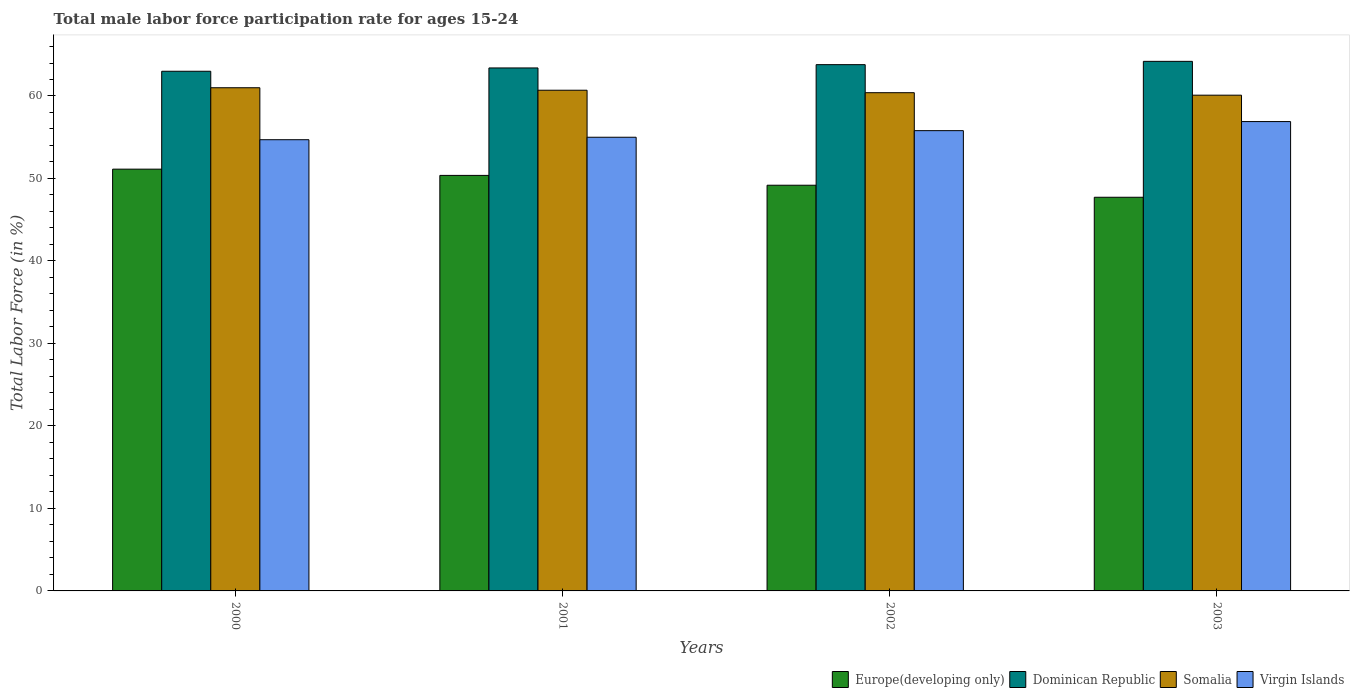How many different coloured bars are there?
Offer a very short reply. 4. Are the number of bars per tick equal to the number of legend labels?
Give a very brief answer. Yes. How many bars are there on the 3rd tick from the left?
Provide a short and direct response. 4. What is the male labor force participation rate in Virgin Islands in 2002?
Keep it short and to the point. 55.8. Across all years, what is the maximum male labor force participation rate in Virgin Islands?
Ensure brevity in your answer.  56.9. Across all years, what is the minimum male labor force participation rate in Somalia?
Ensure brevity in your answer.  60.1. In which year was the male labor force participation rate in Europe(developing only) maximum?
Keep it short and to the point. 2000. What is the total male labor force participation rate in Dominican Republic in the graph?
Your answer should be very brief. 254.4. What is the difference between the male labor force participation rate in Europe(developing only) in 2000 and that in 2002?
Your answer should be very brief. 1.95. What is the difference between the male labor force participation rate in Virgin Islands in 2003 and the male labor force participation rate in Europe(developing only) in 2001?
Make the answer very short. 6.52. What is the average male labor force participation rate in Somalia per year?
Give a very brief answer. 60.55. In the year 2003, what is the difference between the male labor force participation rate in Europe(developing only) and male labor force participation rate in Virgin Islands?
Provide a succinct answer. -9.18. In how many years, is the male labor force participation rate in Europe(developing only) greater than 62 %?
Provide a succinct answer. 0. What is the ratio of the male labor force participation rate in Virgin Islands in 2002 to that in 2003?
Provide a short and direct response. 0.98. Is the difference between the male labor force participation rate in Europe(developing only) in 2001 and 2003 greater than the difference between the male labor force participation rate in Virgin Islands in 2001 and 2003?
Provide a short and direct response. Yes. What is the difference between the highest and the second highest male labor force participation rate in Somalia?
Your response must be concise. 0.3. What is the difference between the highest and the lowest male labor force participation rate in Europe(developing only)?
Your answer should be compact. 3.41. Is the sum of the male labor force participation rate in Dominican Republic in 2001 and 2002 greater than the maximum male labor force participation rate in Somalia across all years?
Offer a terse response. Yes. Is it the case that in every year, the sum of the male labor force participation rate in Dominican Republic and male labor force participation rate in Somalia is greater than the sum of male labor force participation rate in Virgin Islands and male labor force participation rate in Europe(developing only)?
Keep it short and to the point. Yes. What does the 4th bar from the left in 2000 represents?
Provide a succinct answer. Virgin Islands. What does the 4th bar from the right in 2002 represents?
Keep it short and to the point. Europe(developing only). Is it the case that in every year, the sum of the male labor force participation rate in Dominican Republic and male labor force participation rate in Virgin Islands is greater than the male labor force participation rate in Europe(developing only)?
Ensure brevity in your answer.  Yes. Are all the bars in the graph horizontal?
Give a very brief answer. No. What is the difference between two consecutive major ticks on the Y-axis?
Provide a succinct answer. 10. Does the graph contain grids?
Ensure brevity in your answer.  No. How many legend labels are there?
Your response must be concise. 4. How are the legend labels stacked?
Offer a terse response. Horizontal. What is the title of the graph?
Your answer should be compact. Total male labor force participation rate for ages 15-24. Does "Austria" appear as one of the legend labels in the graph?
Your response must be concise. No. What is the label or title of the Y-axis?
Offer a terse response. Total Labor Force (in %). What is the Total Labor Force (in %) in Europe(developing only) in 2000?
Give a very brief answer. 51.13. What is the Total Labor Force (in %) in Dominican Republic in 2000?
Make the answer very short. 63. What is the Total Labor Force (in %) of Somalia in 2000?
Provide a succinct answer. 61. What is the Total Labor Force (in %) in Virgin Islands in 2000?
Keep it short and to the point. 54.7. What is the Total Labor Force (in %) in Europe(developing only) in 2001?
Ensure brevity in your answer.  50.38. What is the Total Labor Force (in %) in Dominican Republic in 2001?
Give a very brief answer. 63.4. What is the Total Labor Force (in %) in Somalia in 2001?
Provide a succinct answer. 60.7. What is the Total Labor Force (in %) of Europe(developing only) in 2002?
Provide a succinct answer. 49.18. What is the Total Labor Force (in %) of Dominican Republic in 2002?
Provide a succinct answer. 63.8. What is the Total Labor Force (in %) of Somalia in 2002?
Provide a succinct answer. 60.4. What is the Total Labor Force (in %) of Virgin Islands in 2002?
Offer a terse response. 55.8. What is the Total Labor Force (in %) in Europe(developing only) in 2003?
Keep it short and to the point. 47.72. What is the Total Labor Force (in %) of Dominican Republic in 2003?
Your answer should be very brief. 64.2. What is the Total Labor Force (in %) in Somalia in 2003?
Keep it short and to the point. 60.1. What is the Total Labor Force (in %) of Virgin Islands in 2003?
Your response must be concise. 56.9. Across all years, what is the maximum Total Labor Force (in %) in Europe(developing only)?
Provide a short and direct response. 51.13. Across all years, what is the maximum Total Labor Force (in %) in Dominican Republic?
Keep it short and to the point. 64.2. Across all years, what is the maximum Total Labor Force (in %) of Somalia?
Keep it short and to the point. 61. Across all years, what is the maximum Total Labor Force (in %) in Virgin Islands?
Ensure brevity in your answer.  56.9. Across all years, what is the minimum Total Labor Force (in %) of Europe(developing only)?
Give a very brief answer. 47.72. Across all years, what is the minimum Total Labor Force (in %) of Dominican Republic?
Your response must be concise. 63. Across all years, what is the minimum Total Labor Force (in %) in Somalia?
Keep it short and to the point. 60.1. Across all years, what is the minimum Total Labor Force (in %) in Virgin Islands?
Make the answer very short. 54.7. What is the total Total Labor Force (in %) in Europe(developing only) in the graph?
Ensure brevity in your answer.  198.42. What is the total Total Labor Force (in %) of Dominican Republic in the graph?
Your response must be concise. 254.4. What is the total Total Labor Force (in %) of Somalia in the graph?
Offer a very short reply. 242.2. What is the total Total Labor Force (in %) in Virgin Islands in the graph?
Your answer should be compact. 222.4. What is the difference between the Total Labor Force (in %) of Europe(developing only) in 2000 and that in 2001?
Your response must be concise. 0.76. What is the difference between the Total Labor Force (in %) of Somalia in 2000 and that in 2001?
Provide a short and direct response. 0.3. What is the difference between the Total Labor Force (in %) in Europe(developing only) in 2000 and that in 2002?
Your answer should be very brief. 1.95. What is the difference between the Total Labor Force (in %) of Dominican Republic in 2000 and that in 2002?
Offer a terse response. -0.8. What is the difference between the Total Labor Force (in %) in Europe(developing only) in 2000 and that in 2003?
Offer a very short reply. 3.41. What is the difference between the Total Labor Force (in %) of Virgin Islands in 2000 and that in 2003?
Make the answer very short. -2.2. What is the difference between the Total Labor Force (in %) of Europe(developing only) in 2001 and that in 2002?
Your response must be concise. 1.19. What is the difference between the Total Labor Force (in %) in Virgin Islands in 2001 and that in 2002?
Your answer should be very brief. -0.8. What is the difference between the Total Labor Force (in %) of Europe(developing only) in 2001 and that in 2003?
Ensure brevity in your answer.  2.65. What is the difference between the Total Labor Force (in %) of Dominican Republic in 2001 and that in 2003?
Provide a succinct answer. -0.8. What is the difference between the Total Labor Force (in %) in Somalia in 2001 and that in 2003?
Keep it short and to the point. 0.6. What is the difference between the Total Labor Force (in %) of Europe(developing only) in 2002 and that in 2003?
Give a very brief answer. 1.46. What is the difference between the Total Labor Force (in %) in Somalia in 2002 and that in 2003?
Your answer should be very brief. 0.3. What is the difference between the Total Labor Force (in %) in Europe(developing only) in 2000 and the Total Labor Force (in %) in Dominican Republic in 2001?
Keep it short and to the point. -12.27. What is the difference between the Total Labor Force (in %) in Europe(developing only) in 2000 and the Total Labor Force (in %) in Somalia in 2001?
Your response must be concise. -9.57. What is the difference between the Total Labor Force (in %) in Europe(developing only) in 2000 and the Total Labor Force (in %) in Virgin Islands in 2001?
Provide a short and direct response. -3.87. What is the difference between the Total Labor Force (in %) of Dominican Republic in 2000 and the Total Labor Force (in %) of Somalia in 2001?
Offer a very short reply. 2.3. What is the difference between the Total Labor Force (in %) in Dominican Republic in 2000 and the Total Labor Force (in %) in Virgin Islands in 2001?
Provide a succinct answer. 8. What is the difference between the Total Labor Force (in %) in Europe(developing only) in 2000 and the Total Labor Force (in %) in Dominican Republic in 2002?
Give a very brief answer. -12.67. What is the difference between the Total Labor Force (in %) in Europe(developing only) in 2000 and the Total Labor Force (in %) in Somalia in 2002?
Your response must be concise. -9.27. What is the difference between the Total Labor Force (in %) in Europe(developing only) in 2000 and the Total Labor Force (in %) in Virgin Islands in 2002?
Your response must be concise. -4.67. What is the difference between the Total Labor Force (in %) in Somalia in 2000 and the Total Labor Force (in %) in Virgin Islands in 2002?
Provide a short and direct response. 5.2. What is the difference between the Total Labor Force (in %) in Europe(developing only) in 2000 and the Total Labor Force (in %) in Dominican Republic in 2003?
Offer a terse response. -13.07. What is the difference between the Total Labor Force (in %) of Europe(developing only) in 2000 and the Total Labor Force (in %) of Somalia in 2003?
Your answer should be very brief. -8.97. What is the difference between the Total Labor Force (in %) in Europe(developing only) in 2000 and the Total Labor Force (in %) in Virgin Islands in 2003?
Your answer should be compact. -5.77. What is the difference between the Total Labor Force (in %) of Dominican Republic in 2000 and the Total Labor Force (in %) of Somalia in 2003?
Make the answer very short. 2.9. What is the difference between the Total Labor Force (in %) of Somalia in 2000 and the Total Labor Force (in %) of Virgin Islands in 2003?
Provide a short and direct response. 4.1. What is the difference between the Total Labor Force (in %) in Europe(developing only) in 2001 and the Total Labor Force (in %) in Dominican Republic in 2002?
Your answer should be compact. -13.42. What is the difference between the Total Labor Force (in %) in Europe(developing only) in 2001 and the Total Labor Force (in %) in Somalia in 2002?
Your response must be concise. -10.02. What is the difference between the Total Labor Force (in %) in Europe(developing only) in 2001 and the Total Labor Force (in %) in Virgin Islands in 2002?
Offer a terse response. -5.42. What is the difference between the Total Labor Force (in %) in Dominican Republic in 2001 and the Total Labor Force (in %) in Virgin Islands in 2002?
Provide a short and direct response. 7.6. What is the difference between the Total Labor Force (in %) of Somalia in 2001 and the Total Labor Force (in %) of Virgin Islands in 2002?
Provide a short and direct response. 4.9. What is the difference between the Total Labor Force (in %) in Europe(developing only) in 2001 and the Total Labor Force (in %) in Dominican Republic in 2003?
Your answer should be very brief. -13.82. What is the difference between the Total Labor Force (in %) of Europe(developing only) in 2001 and the Total Labor Force (in %) of Somalia in 2003?
Offer a very short reply. -9.72. What is the difference between the Total Labor Force (in %) of Europe(developing only) in 2001 and the Total Labor Force (in %) of Virgin Islands in 2003?
Your answer should be compact. -6.52. What is the difference between the Total Labor Force (in %) in Somalia in 2001 and the Total Labor Force (in %) in Virgin Islands in 2003?
Keep it short and to the point. 3.8. What is the difference between the Total Labor Force (in %) in Europe(developing only) in 2002 and the Total Labor Force (in %) in Dominican Republic in 2003?
Provide a succinct answer. -15.02. What is the difference between the Total Labor Force (in %) in Europe(developing only) in 2002 and the Total Labor Force (in %) in Somalia in 2003?
Provide a short and direct response. -10.92. What is the difference between the Total Labor Force (in %) of Europe(developing only) in 2002 and the Total Labor Force (in %) of Virgin Islands in 2003?
Provide a short and direct response. -7.72. What is the average Total Labor Force (in %) in Europe(developing only) per year?
Ensure brevity in your answer.  49.6. What is the average Total Labor Force (in %) in Dominican Republic per year?
Your answer should be compact. 63.6. What is the average Total Labor Force (in %) of Somalia per year?
Offer a terse response. 60.55. What is the average Total Labor Force (in %) of Virgin Islands per year?
Make the answer very short. 55.6. In the year 2000, what is the difference between the Total Labor Force (in %) in Europe(developing only) and Total Labor Force (in %) in Dominican Republic?
Your answer should be very brief. -11.87. In the year 2000, what is the difference between the Total Labor Force (in %) of Europe(developing only) and Total Labor Force (in %) of Somalia?
Provide a succinct answer. -9.87. In the year 2000, what is the difference between the Total Labor Force (in %) of Europe(developing only) and Total Labor Force (in %) of Virgin Islands?
Provide a succinct answer. -3.57. In the year 2000, what is the difference between the Total Labor Force (in %) of Dominican Republic and Total Labor Force (in %) of Virgin Islands?
Offer a very short reply. 8.3. In the year 2001, what is the difference between the Total Labor Force (in %) in Europe(developing only) and Total Labor Force (in %) in Dominican Republic?
Your answer should be compact. -13.02. In the year 2001, what is the difference between the Total Labor Force (in %) in Europe(developing only) and Total Labor Force (in %) in Somalia?
Provide a short and direct response. -10.32. In the year 2001, what is the difference between the Total Labor Force (in %) of Europe(developing only) and Total Labor Force (in %) of Virgin Islands?
Give a very brief answer. -4.62. In the year 2001, what is the difference between the Total Labor Force (in %) of Dominican Republic and Total Labor Force (in %) of Virgin Islands?
Offer a very short reply. 8.4. In the year 2002, what is the difference between the Total Labor Force (in %) of Europe(developing only) and Total Labor Force (in %) of Dominican Republic?
Ensure brevity in your answer.  -14.62. In the year 2002, what is the difference between the Total Labor Force (in %) in Europe(developing only) and Total Labor Force (in %) in Somalia?
Provide a short and direct response. -11.22. In the year 2002, what is the difference between the Total Labor Force (in %) in Europe(developing only) and Total Labor Force (in %) in Virgin Islands?
Your answer should be very brief. -6.62. In the year 2002, what is the difference between the Total Labor Force (in %) of Somalia and Total Labor Force (in %) of Virgin Islands?
Your response must be concise. 4.6. In the year 2003, what is the difference between the Total Labor Force (in %) of Europe(developing only) and Total Labor Force (in %) of Dominican Republic?
Give a very brief answer. -16.48. In the year 2003, what is the difference between the Total Labor Force (in %) of Europe(developing only) and Total Labor Force (in %) of Somalia?
Ensure brevity in your answer.  -12.38. In the year 2003, what is the difference between the Total Labor Force (in %) of Europe(developing only) and Total Labor Force (in %) of Virgin Islands?
Offer a terse response. -9.18. What is the ratio of the Total Labor Force (in %) of Dominican Republic in 2000 to that in 2001?
Give a very brief answer. 0.99. What is the ratio of the Total Labor Force (in %) of Virgin Islands in 2000 to that in 2001?
Provide a short and direct response. 0.99. What is the ratio of the Total Labor Force (in %) in Europe(developing only) in 2000 to that in 2002?
Your answer should be compact. 1.04. What is the ratio of the Total Labor Force (in %) in Dominican Republic in 2000 to that in 2002?
Give a very brief answer. 0.99. What is the ratio of the Total Labor Force (in %) in Somalia in 2000 to that in 2002?
Provide a succinct answer. 1.01. What is the ratio of the Total Labor Force (in %) of Virgin Islands in 2000 to that in 2002?
Your answer should be compact. 0.98. What is the ratio of the Total Labor Force (in %) in Europe(developing only) in 2000 to that in 2003?
Offer a very short reply. 1.07. What is the ratio of the Total Labor Force (in %) in Dominican Republic in 2000 to that in 2003?
Your answer should be compact. 0.98. What is the ratio of the Total Labor Force (in %) of Virgin Islands in 2000 to that in 2003?
Give a very brief answer. 0.96. What is the ratio of the Total Labor Force (in %) of Europe(developing only) in 2001 to that in 2002?
Keep it short and to the point. 1.02. What is the ratio of the Total Labor Force (in %) of Virgin Islands in 2001 to that in 2002?
Offer a terse response. 0.99. What is the ratio of the Total Labor Force (in %) in Europe(developing only) in 2001 to that in 2003?
Offer a very short reply. 1.06. What is the ratio of the Total Labor Force (in %) in Dominican Republic in 2001 to that in 2003?
Ensure brevity in your answer.  0.99. What is the ratio of the Total Labor Force (in %) in Virgin Islands in 2001 to that in 2003?
Offer a very short reply. 0.97. What is the ratio of the Total Labor Force (in %) in Europe(developing only) in 2002 to that in 2003?
Ensure brevity in your answer.  1.03. What is the ratio of the Total Labor Force (in %) of Dominican Republic in 2002 to that in 2003?
Offer a terse response. 0.99. What is the ratio of the Total Labor Force (in %) in Virgin Islands in 2002 to that in 2003?
Provide a short and direct response. 0.98. What is the difference between the highest and the second highest Total Labor Force (in %) of Europe(developing only)?
Make the answer very short. 0.76. What is the difference between the highest and the second highest Total Labor Force (in %) in Dominican Republic?
Provide a succinct answer. 0.4. What is the difference between the highest and the lowest Total Labor Force (in %) of Europe(developing only)?
Provide a short and direct response. 3.41. What is the difference between the highest and the lowest Total Labor Force (in %) of Somalia?
Ensure brevity in your answer.  0.9. 